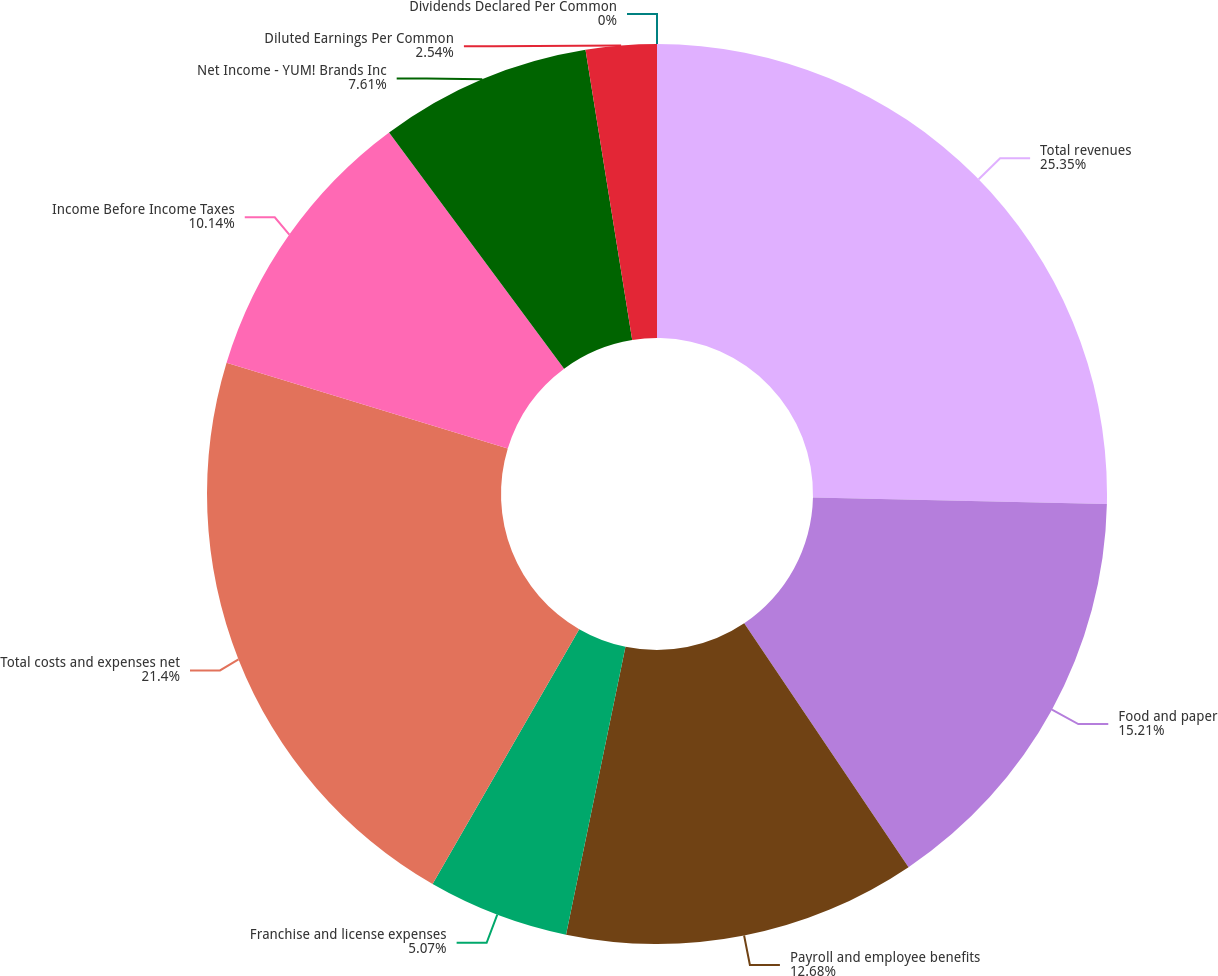Convert chart. <chart><loc_0><loc_0><loc_500><loc_500><pie_chart><fcel>Total revenues<fcel>Food and paper<fcel>Payroll and employee benefits<fcel>Franchise and license expenses<fcel>Total costs and expenses net<fcel>Income Before Income Taxes<fcel>Net Income - YUM! Brands Inc<fcel>Diluted Earnings Per Common<fcel>Dividends Declared Per Common<nl><fcel>25.35%<fcel>15.21%<fcel>12.68%<fcel>5.07%<fcel>21.4%<fcel>10.14%<fcel>7.61%<fcel>2.54%<fcel>0.0%<nl></chart> 